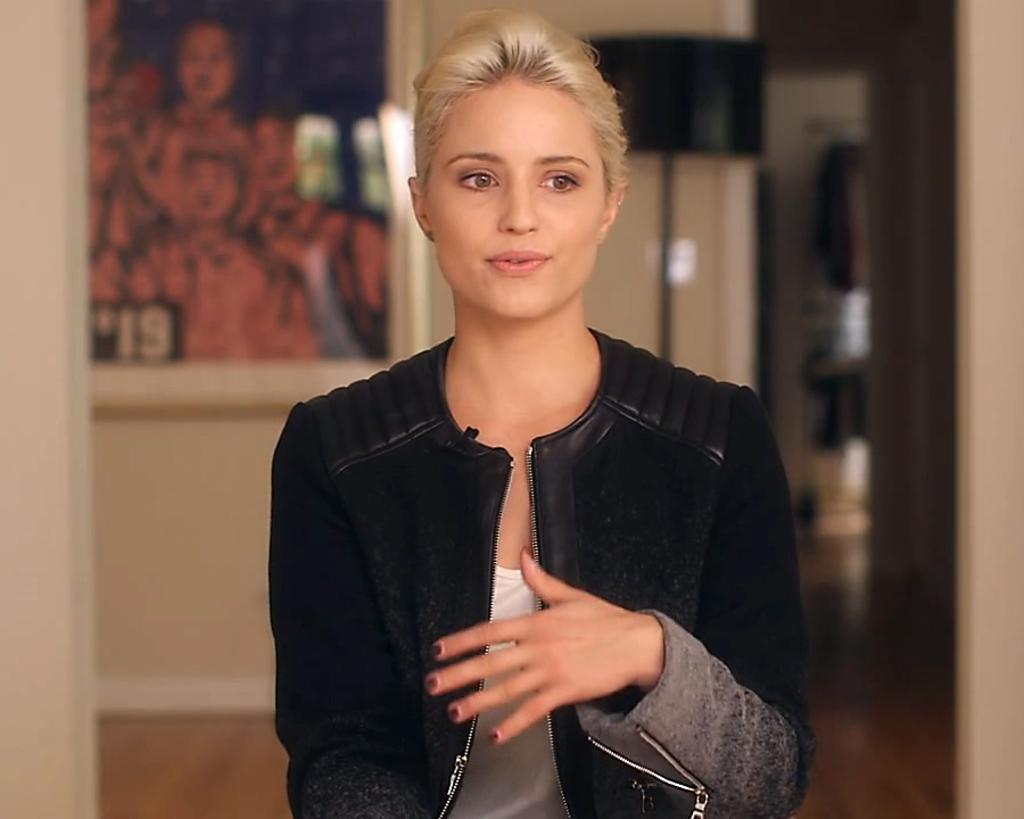In one or two sentences, can you explain what this image depicts? In the image we can see a woman wearing clothes and this is a lamp, frame and a floor. 